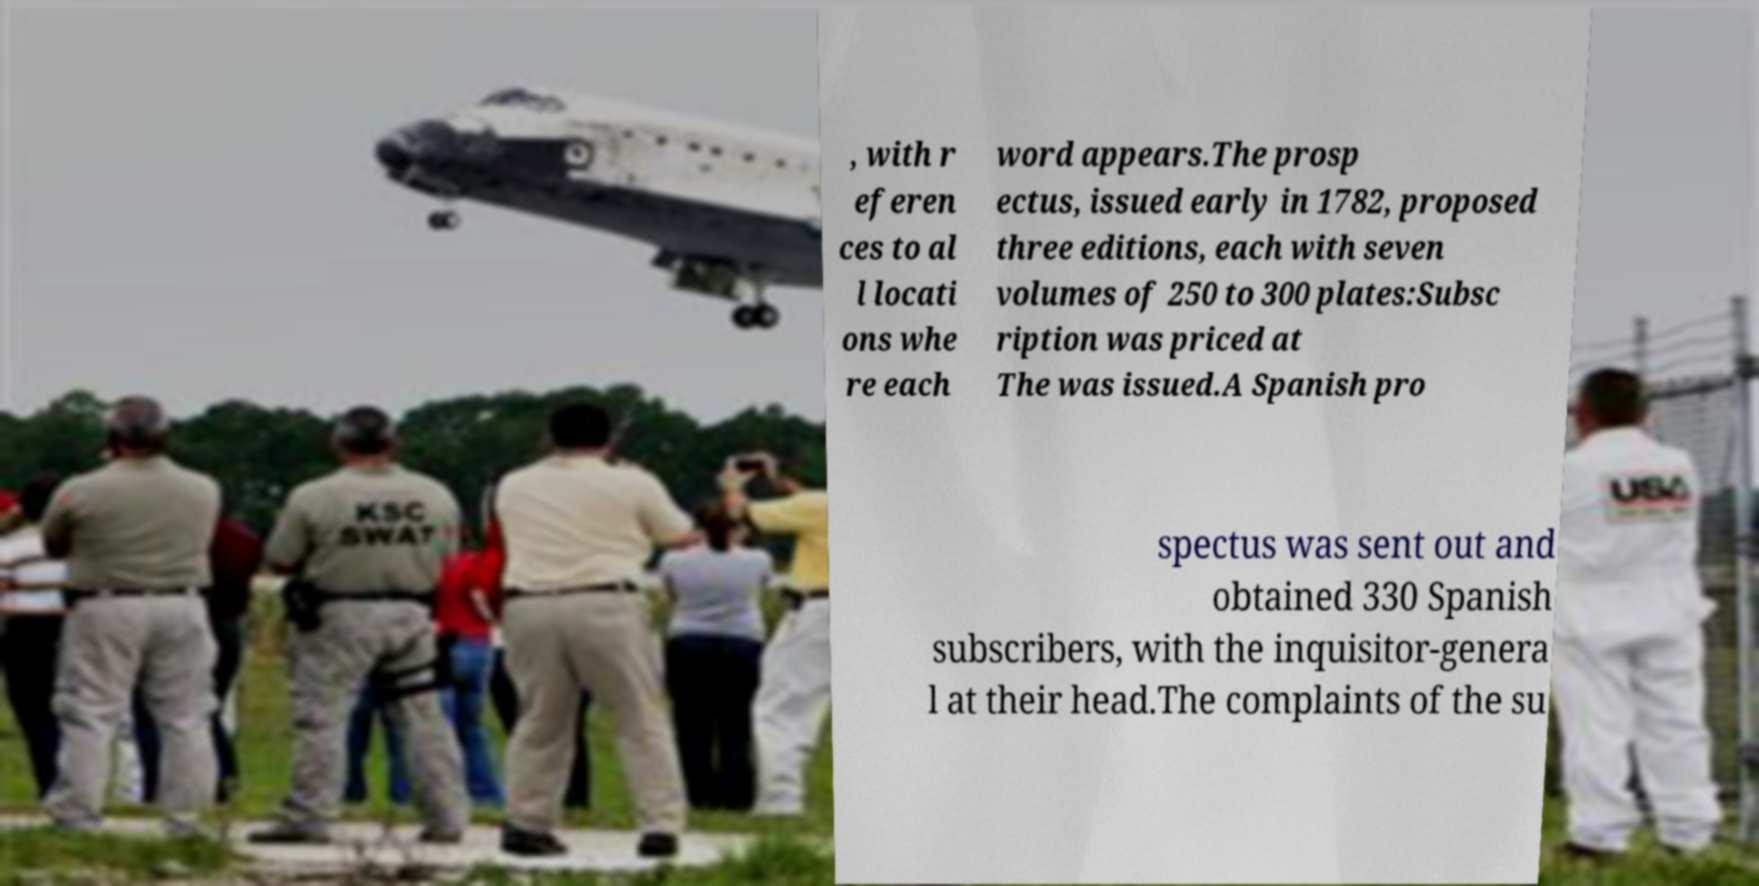Could you assist in decoding the text presented in this image and type it out clearly? , with r eferen ces to al l locati ons whe re each word appears.The prosp ectus, issued early in 1782, proposed three editions, each with seven volumes of 250 to 300 plates:Subsc ription was priced at The was issued.A Spanish pro spectus was sent out and obtained 330 Spanish subscribers, with the inquisitor-genera l at their head.The complaints of the su 